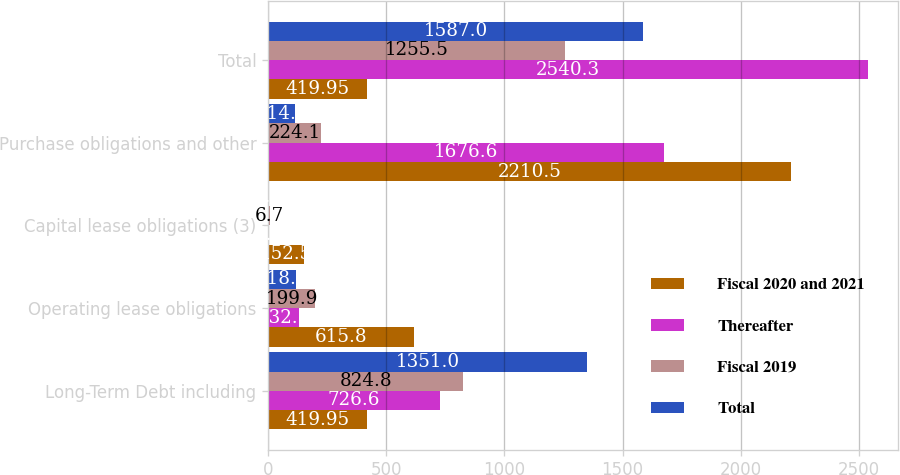Convert chart. <chart><loc_0><loc_0><loc_500><loc_500><stacked_bar_chart><ecel><fcel>Long-Term Debt including<fcel>Operating lease obligations<fcel>Capital lease obligations (3)<fcel>Purchase obligations and other<fcel>Total<nl><fcel>Fiscal 2020 and 2021<fcel>419.95<fcel>615.8<fcel>152.5<fcel>2210.5<fcel>419.95<nl><fcel>Thereafter<fcel>726.6<fcel>132.1<fcel>5<fcel>1676.6<fcel>2540.3<nl><fcel>Fiscal 2019<fcel>824.8<fcel>199.9<fcel>6.7<fcel>224.1<fcel>1255.5<nl><fcel>Total<fcel>1351<fcel>118.4<fcel>2.7<fcel>114.9<fcel>1587<nl></chart> 